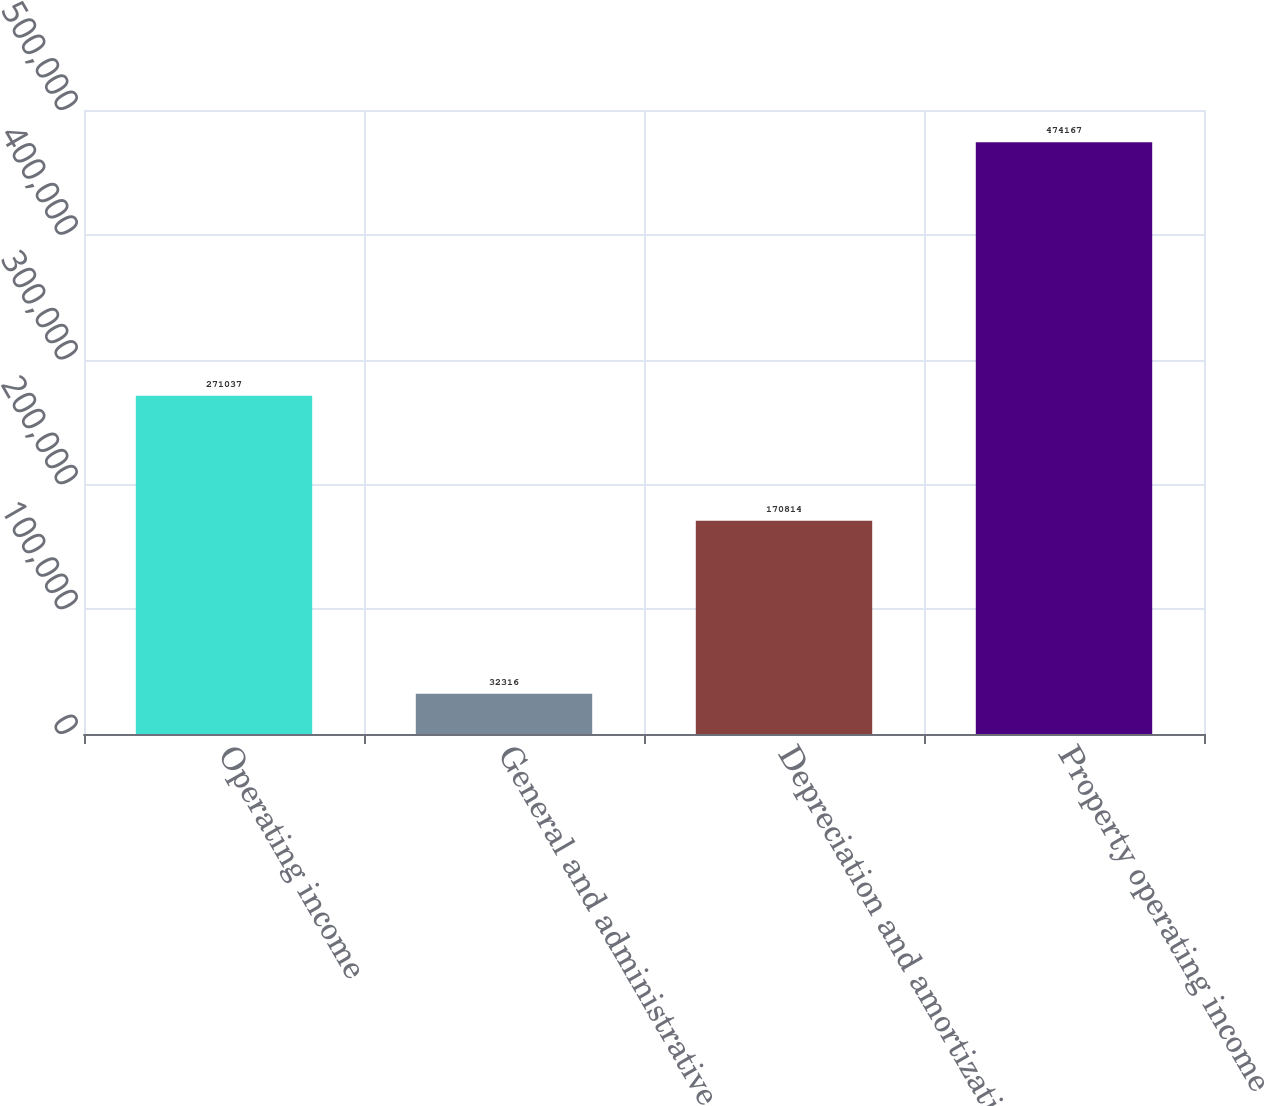Convert chart. <chart><loc_0><loc_0><loc_500><loc_500><bar_chart><fcel>Operating income<fcel>General and administrative<fcel>Depreciation and amortization<fcel>Property operating income<nl><fcel>271037<fcel>32316<fcel>170814<fcel>474167<nl></chart> 